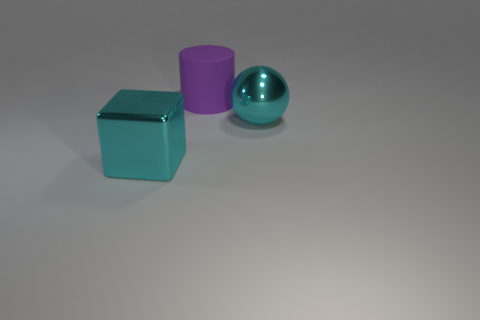Subtract all cubes. How many objects are left? 2 Add 3 big cyan metallic objects. How many objects exist? 6 Add 3 metal objects. How many metal objects are left? 5 Add 1 metal spheres. How many metal spheres exist? 2 Subtract 1 cyan balls. How many objects are left? 2 Subtract 1 cylinders. How many cylinders are left? 0 Subtract all gray cylinders. Subtract all brown balls. How many cylinders are left? 1 Subtract all tiny brown balls. Subtract all large cyan objects. How many objects are left? 1 